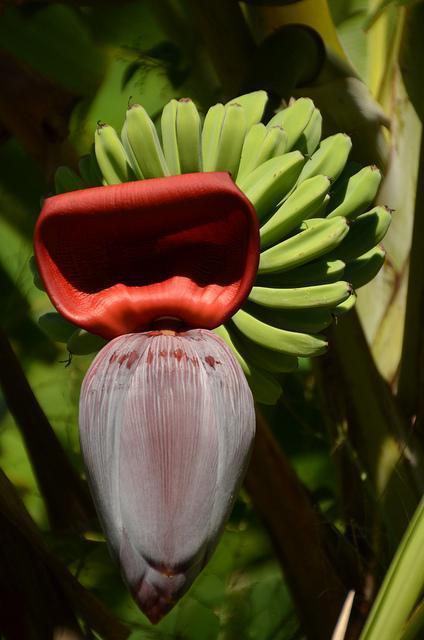How many men are wearing blue jeans?
Give a very brief answer. 0. 